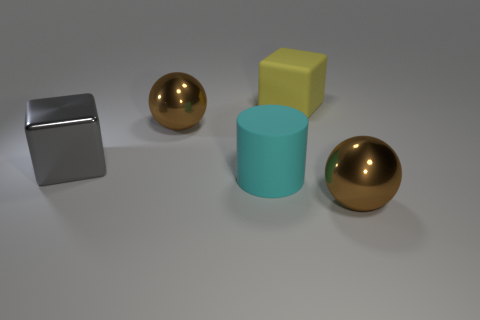Is there a big object made of the same material as the gray cube?
Offer a very short reply. Yes. The rubber cube is what color?
Your response must be concise. Yellow. What is the size of the metal cube on the left side of the cyan matte thing?
Keep it short and to the point. Large. What number of large metal spheres have the same color as the matte cube?
Your answer should be very brief. 0. Are there any big cubes that are behind the large brown metallic sphere in front of the large cyan thing?
Offer a very short reply. Yes. There is a metallic ball that is to the right of the big cylinder; does it have the same color as the metallic sphere behind the cyan rubber thing?
Offer a terse response. Yes. What is the color of the metallic block that is the same size as the matte cylinder?
Make the answer very short. Gray. Are there an equal number of cyan rubber cylinders that are left of the matte cylinder and big rubber cylinders that are on the right side of the big yellow matte cube?
Offer a terse response. Yes. What material is the big brown sphere to the left of the shiny ball on the right side of the yellow block made of?
Offer a very short reply. Metal. What number of things are either big metal balls or red rubber balls?
Keep it short and to the point. 2. 